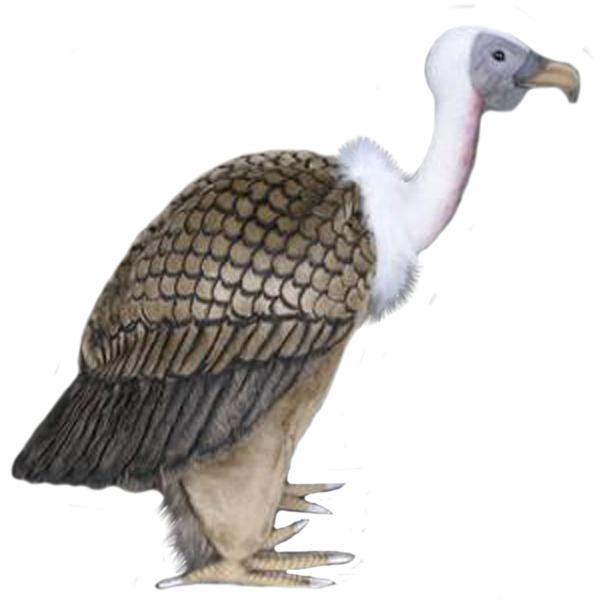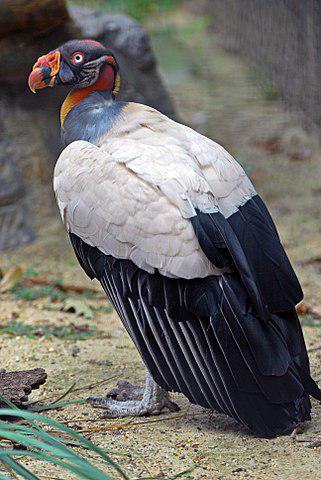The first image is the image on the left, the second image is the image on the right. Analyze the images presented: Is the assertion "The vulture on the left has a white neck and brown wings." valid? Answer yes or no. Yes. 